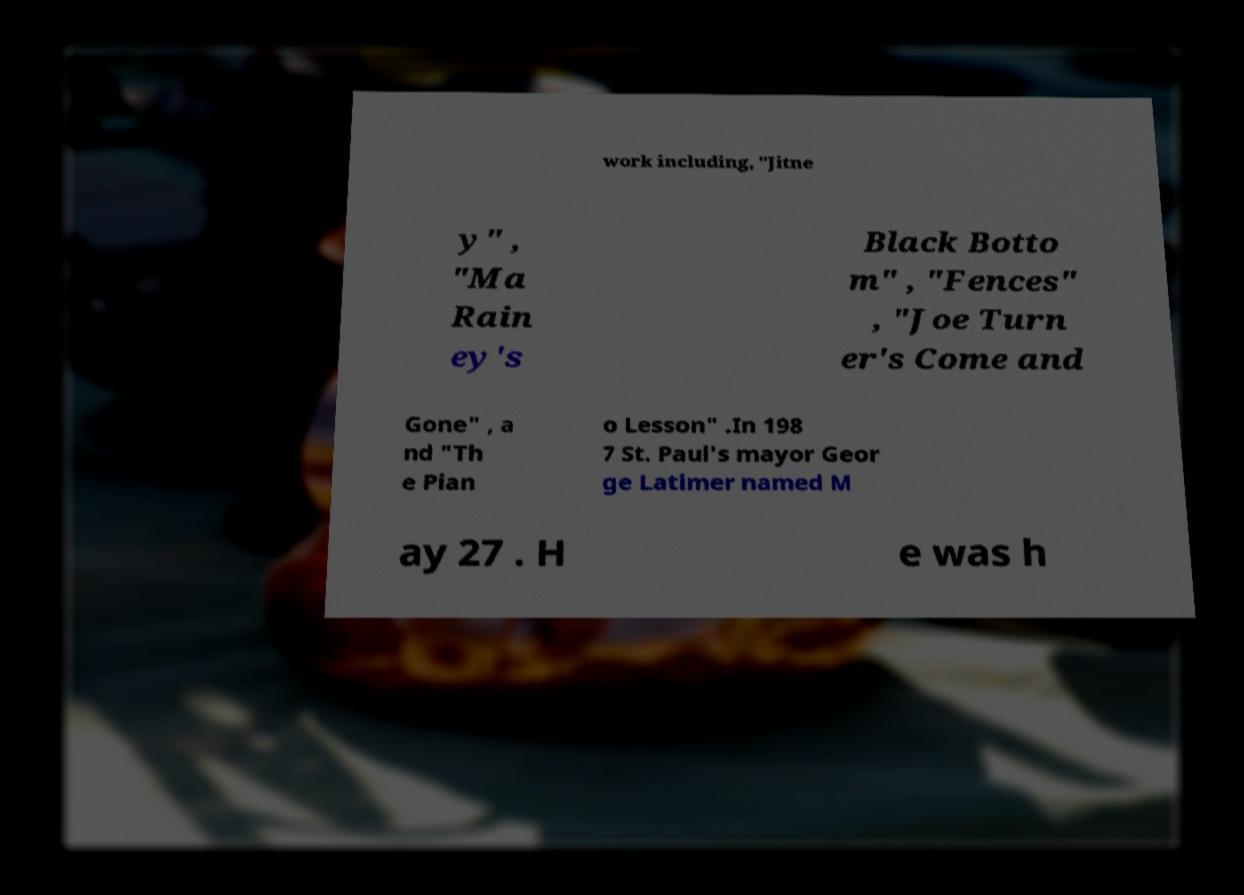What messages or text are displayed in this image? I need them in a readable, typed format. work including, "Jitne y" , "Ma Rain ey's Black Botto m" , "Fences" , "Joe Turn er's Come and Gone" , a nd "Th e Pian o Lesson" .In 198 7 St. Paul's mayor Geor ge Latimer named M ay 27 . H e was h 